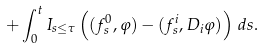Convert formula to latex. <formula><loc_0><loc_0><loc_500><loc_500>+ \int _ { 0 } ^ { t } I _ { s \leq \tau } \left ( ( f ^ { 0 } _ { s } , \varphi ) - ( f ^ { i } _ { s } , D _ { i } \varphi ) \right ) \, d s .</formula> 